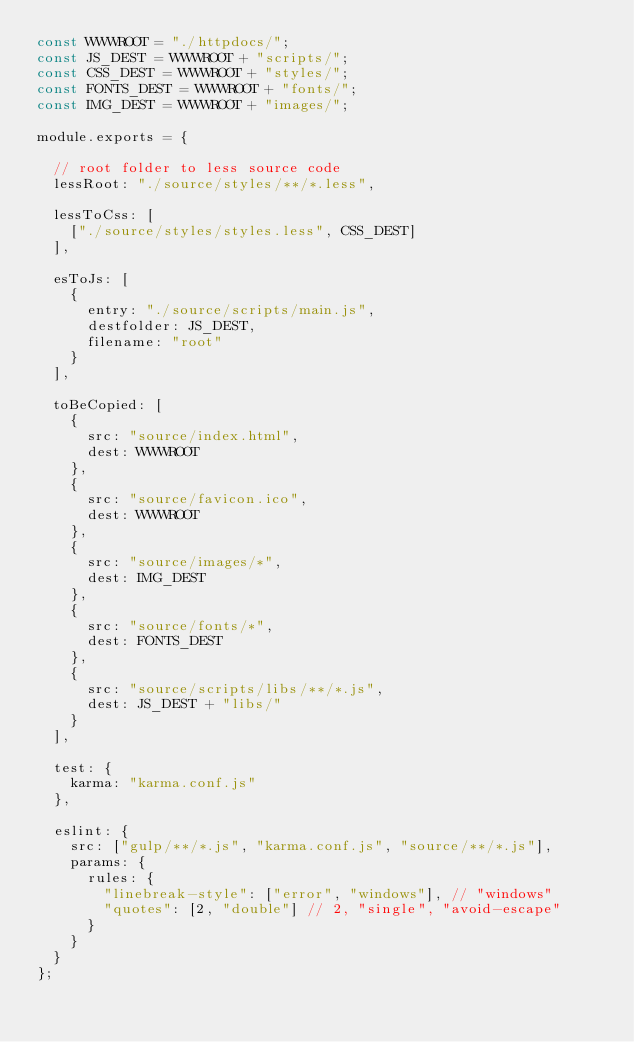Convert code to text. <code><loc_0><loc_0><loc_500><loc_500><_JavaScript_>const WWWROOT = "./httpdocs/";
const JS_DEST = WWWROOT + "scripts/";
const CSS_DEST = WWWROOT + "styles/";
const FONTS_DEST = WWWROOT + "fonts/";
const IMG_DEST = WWWROOT + "images/";

module.exports = {

  // root folder to less source code
  lessRoot: "./source/styles/**/*.less",

  lessToCss: [
    ["./source/styles/styles.less", CSS_DEST]
  ],
  
  esToJs: [
    {
      entry: "./source/scripts/main.js",
      destfolder: JS_DEST,
      filename: "root"
    }
  ],

  toBeCopied: [
    {
      src: "source/index.html",
      dest: WWWROOT
    },
    {
      src: "source/favicon.ico",
      dest: WWWROOT
    },
    {
      src: "source/images/*",
      dest: IMG_DEST
    },
    {
      src: "source/fonts/*",
      dest: FONTS_DEST
    },
    {
      src: "source/scripts/libs/**/*.js",
      dest: JS_DEST + "libs/"
    }
  ],

  test: {
    karma: "karma.conf.js"
  },

  eslint: {
    src: ["gulp/**/*.js", "karma.conf.js", "source/**/*.js"],
    params: {
      rules: {
        "linebreak-style": ["error", "windows"], // "windows"
        "quotes": [2, "double"] // 2, "single", "avoid-escape"
      }
    }
  }
};
</code> 